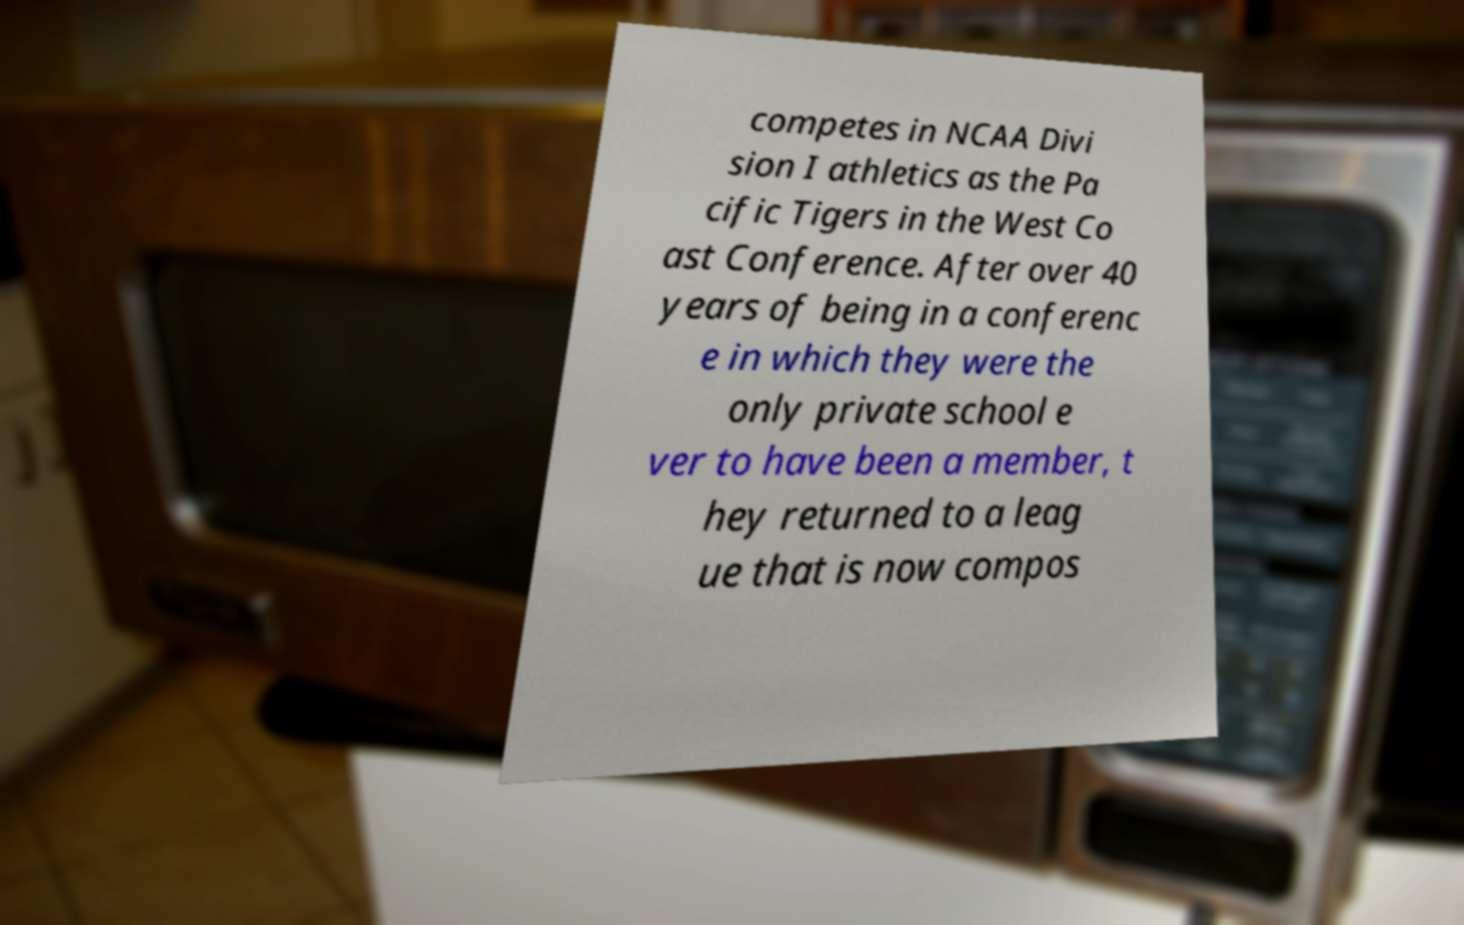There's text embedded in this image that I need extracted. Can you transcribe it verbatim? competes in NCAA Divi sion I athletics as the Pa cific Tigers in the West Co ast Conference. After over 40 years of being in a conferenc e in which they were the only private school e ver to have been a member, t hey returned to a leag ue that is now compos 